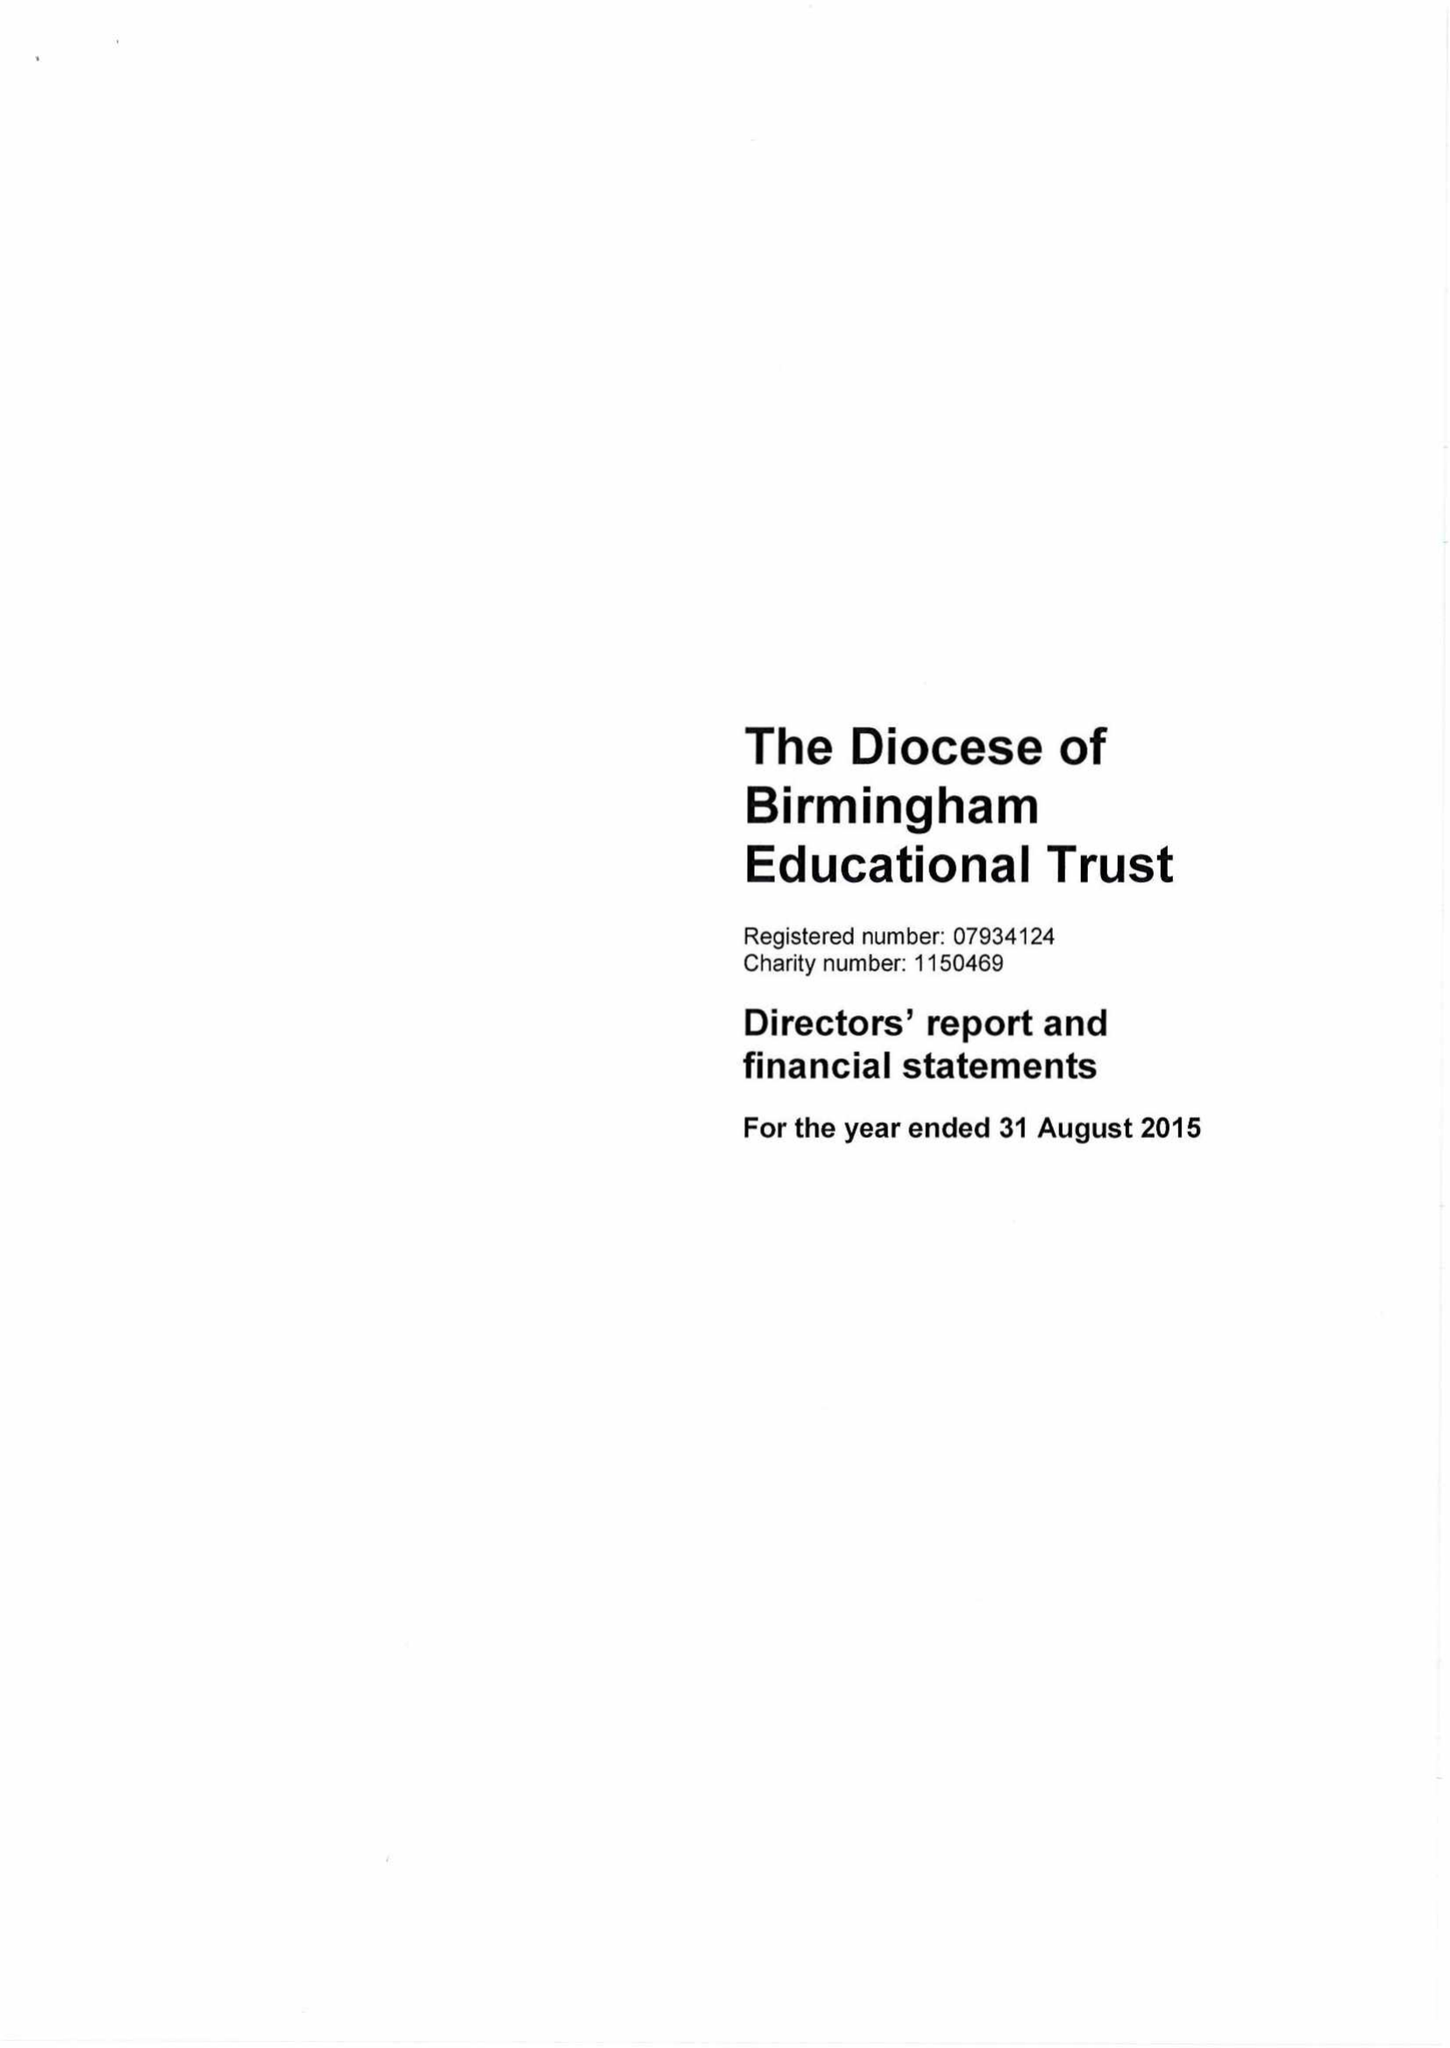What is the value for the charity_name?
Answer the question using a single word or phrase. The Diocese Of Birmingham Educational Trust 